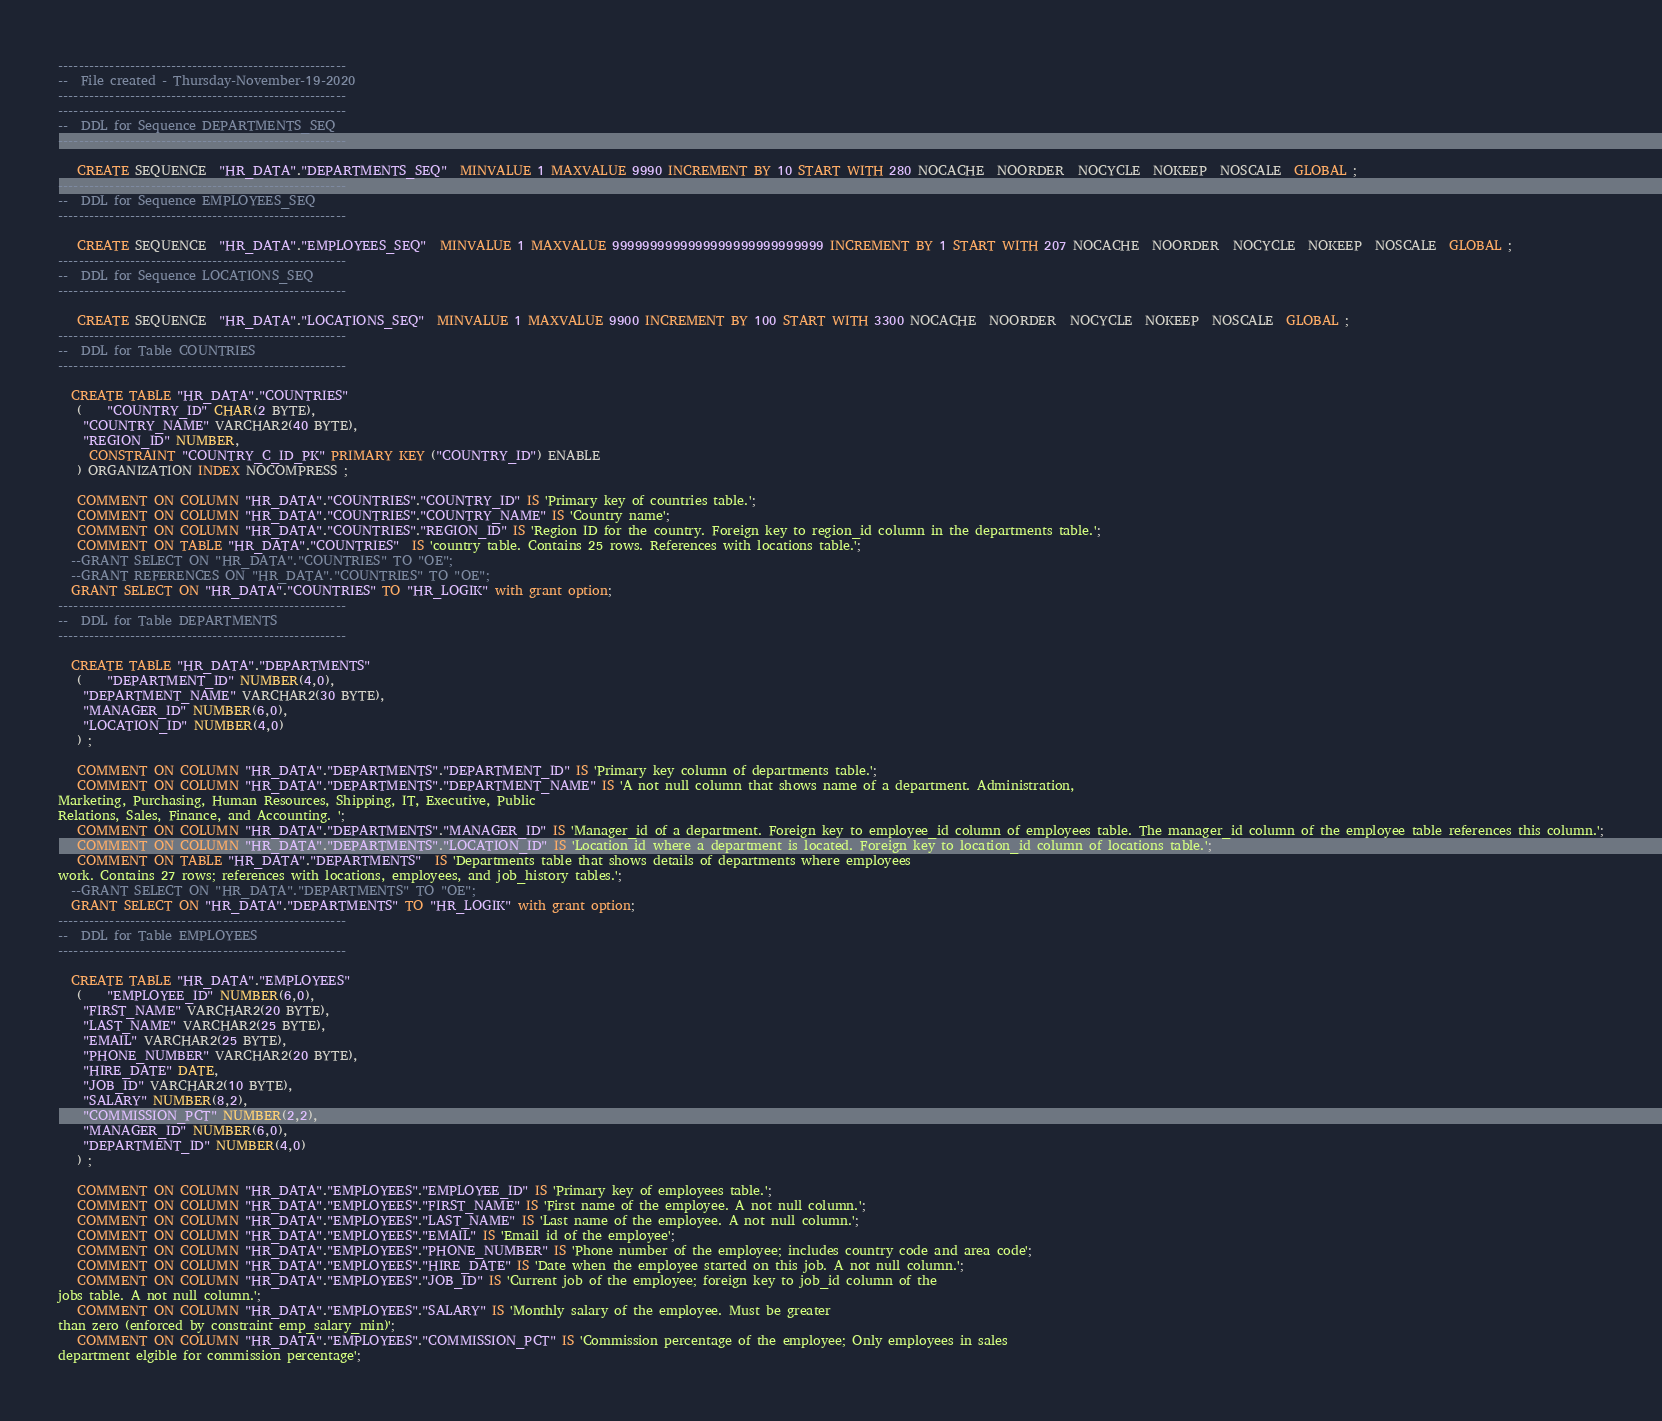<code> <loc_0><loc_0><loc_500><loc_500><_SQL_>--------------------------------------------------------
--  File created - Thursday-November-19-2020   
--------------------------------------------------------
--------------------------------------------------------
--  DDL for Sequence DEPARTMENTS_SEQ
--------------------------------------------------------

   CREATE SEQUENCE  "HR_DATA"."DEPARTMENTS_SEQ"  MINVALUE 1 MAXVALUE 9990 INCREMENT BY 10 START WITH 280 NOCACHE  NOORDER  NOCYCLE  NOKEEP  NOSCALE  GLOBAL ;
--------------------------------------------------------
--  DDL for Sequence EMPLOYEES_SEQ
--------------------------------------------------------

   CREATE SEQUENCE  "HR_DATA"."EMPLOYEES_SEQ"  MINVALUE 1 MAXVALUE 9999999999999999999999999999 INCREMENT BY 1 START WITH 207 NOCACHE  NOORDER  NOCYCLE  NOKEEP  NOSCALE  GLOBAL ;
--------------------------------------------------------
--  DDL for Sequence LOCATIONS_SEQ
--------------------------------------------------------

   CREATE SEQUENCE  "HR_DATA"."LOCATIONS_SEQ"  MINVALUE 1 MAXVALUE 9900 INCREMENT BY 100 START WITH 3300 NOCACHE  NOORDER  NOCYCLE  NOKEEP  NOSCALE  GLOBAL ;
--------------------------------------------------------
--  DDL for Table COUNTRIES
--------------------------------------------------------

  CREATE TABLE "HR_DATA"."COUNTRIES" 
   (	"COUNTRY_ID" CHAR(2 BYTE), 
	"COUNTRY_NAME" VARCHAR2(40 BYTE), 
	"REGION_ID" NUMBER, 
	 CONSTRAINT "COUNTRY_C_ID_PK" PRIMARY KEY ("COUNTRY_ID") ENABLE
   ) ORGANIZATION INDEX NOCOMPRESS ;

   COMMENT ON COLUMN "HR_DATA"."COUNTRIES"."COUNTRY_ID" IS 'Primary key of countries table.';
   COMMENT ON COLUMN "HR_DATA"."COUNTRIES"."COUNTRY_NAME" IS 'Country name';
   COMMENT ON COLUMN "HR_DATA"."COUNTRIES"."REGION_ID" IS 'Region ID for the country. Foreign key to region_id column in the departments table.';
   COMMENT ON TABLE "HR_DATA"."COUNTRIES"  IS 'country table. Contains 25 rows. References with locations table.';
  --GRANT SELECT ON "HR_DATA"."COUNTRIES" TO "OE";
  --GRANT REFERENCES ON "HR_DATA"."COUNTRIES" TO "OE";
  GRANT SELECT ON "HR_DATA"."COUNTRIES" TO "HR_LOGIK" with grant option;
--------------------------------------------------------
--  DDL for Table DEPARTMENTS
--------------------------------------------------------

  CREATE TABLE "HR_DATA"."DEPARTMENTS" 
   (	"DEPARTMENT_ID" NUMBER(4,0), 
	"DEPARTMENT_NAME" VARCHAR2(30 BYTE), 
	"MANAGER_ID" NUMBER(6,0), 
	"LOCATION_ID" NUMBER(4,0)
   ) ;

   COMMENT ON COLUMN "HR_DATA"."DEPARTMENTS"."DEPARTMENT_ID" IS 'Primary key column of departments table.';
   COMMENT ON COLUMN "HR_DATA"."DEPARTMENTS"."DEPARTMENT_NAME" IS 'A not null column that shows name of a department. Administration,
Marketing, Purchasing, Human Resources, Shipping, IT, Executive, Public
Relations, Sales, Finance, and Accounting. ';
   COMMENT ON COLUMN "HR_DATA"."DEPARTMENTS"."MANAGER_ID" IS 'Manager_id of a department. Foreign key to employee_id column of employees table. The manager_id column of the employee table references this column.';
   COMMENT ON COLUMN "HR_DATA"."DEPARTMENTS"."LOCATION_ID" IS 'Location id where a department is located. Foreign key to location_id column of locations table.';
   COMMENT ON TABLE "HR_DATA"."DEPARTMENTS"  IS 'Departments table that shows details of departments where employees
work. Contains 27 rows; references with locations, employees, and job_history tables.';
  --GRANT SELECT ON "HR_DATA"."DEPARTMENTS" TO "OE";
  GRANT SELECT ON "HR_DATA"."DEPARTMENTS" TO "HR_LOGIK" with grant option;
--------------------------------------------------------
--  DDL for Table EMPLOYEES
--------------------------------------------------------

  CREATE TABLE "HR_DATA"."EMPLOYEES" 
   (	"EMPLOYEE_ID" NUMBER(6,0), 
	"FIRST_NAME" VARCHAR2(20 BYTE), 
	"LAST_NAME" VARCHAR2(25 BYTE), 
	"EMAIL" VARCHAR2(25 BYTE), 
	"PHONE_NUMBER" VARCHAR2(20 BYTE), 
	"HIRE_DATE" DATE, 
	"JOB_ID" VARCHAR2(10 BYTE), 
	"SALARY" NUMBER(8,2), 
	"COMMISSION_PCT" NUMBER(2,2), 
	"MANAGER_ID" NUMBER(6,0), 
	"DEPARTMENT_ID" NUMBER(4,0)
   ) ;

   COMMENT ON COLUMN "HR_DATA"."EMPLOYEES"."EMPLOYEE_ID" IS 'Primary key of employees table.';
   COMMENT ON COLUMN "HR_DATA"."EMPLOYEES"."FIRST_NAME" IS 'First name of the employee. A not null column.';
   COMMENT ON COLUMN "HR_DATA"."EMPLOYEES"."LAST_NAME" IS 'Last name of the employee. A not null column.';
   COMMENT ON COLUMN "HR_DATA"."EMPLOYEES"."EMAIL" IS 'Email id of the employee';
   COMMENT ON COLUMN "HR_DATA"."EMPLOYEES"."PHONE_NUMBER" IS 'Phone number of the employee; includes country code and area code';
   COMMENT ON COLUMN "HR_DATA"."EMPLOYEES"."HIRE_DATE" IS 'Date when the employee started on this job. A not null column.';
   COMMENT ON COLUMN "HR_DATA"."EMPLOYEES"."JOB_ID" IS 'Current job of the employee; foreign key to job_id column of the
jobs table. A not null column.';
   COMMENT ON COLUMN "HR_DATA"."EMPLOYEES"."SALARY" IS 'Monthly salary of the employee. Must be greater
than zero (enforced by constraint emp_salary_min)';
   COMMENT ON COLUMN "HR_DATA"."EMPLOYEES"."COMMISSION_PCT" IS 'Commission percentage of the employee; Only employees in sales
department elgible for commission percentage';</code> 